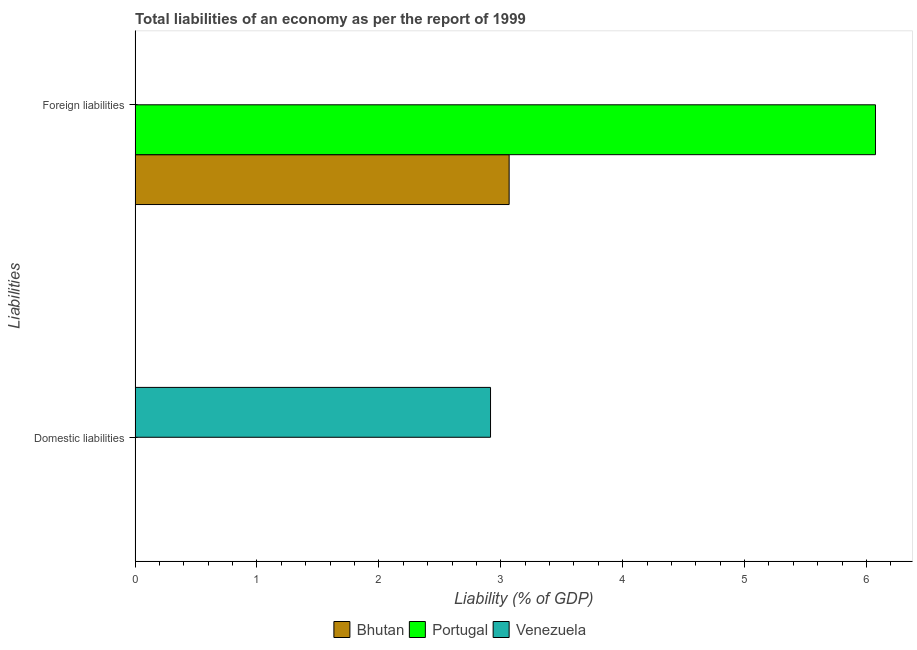How many different coloured bars are there?
Make the answer very short. 3. How many bars are there on the 2nd tick from the top?
Your answer should be very brief. 1. What is the label of the 2nd group of bars from the top?
Offer a very short reply. Domestic liabilities. What is the incurrence of foreign liabilities in Portugal?
Offer a very short reply. 6.07. Across all countries, what is the maximum incurrence of domestic liabilities?
Keep it short and to the point. 2.92. Across all countries, what is the minimum incurrence of domestic liabilities?
Provide a short and direct response. 0. What is the total incurrence of foreign liabilities in the graph?
Provide a short and direct response. 9.14. What is the difference between the incurrence of foreign liabilities in Portugal and that in Bhutan?
Give a very brief answer. 3.01. What is the difference between the incurrence of domestic liabilities in Venezuela and the incurrence of foreign liabilities in Portugal?
Ensure brevity in your answer.  -3.16. What is the average incurrence of domestic liabilities per country?
Keep it short and to the point. 0.97. In how many countries, is the incurrence of foreign liabilities greater than 4.4 %?
Give a very brief answer. 1. What is the ratio of the incurrence of foreign liabilities in Portugal to that in Bhutan?
Ensure brevity in your answer.  1.98. How many bars are there?
Offer a terse response. 3. Does the graph contain any zero values?
Offer a very short reply. Yes. Where does the legend appear in the graph?
Give a very brief answer. Bottom center. How many legend labels are there?
Make the answer very short. 3. How are the legend labels stacked?
Ensure brevity in your answer.  Horizontal. What is the title of the graph?
Provide a succinct answer. Total liabilities of an economy as per the report of 1999. Does "Sweden" appear as one of the legend labels in the graph?
Your answer should be very brief. No. What is the label or title of the X-axis?
Provide a short and direct response. Liability (% of GDP). What is the label or title of the Y-axis?
Offer a terse response. Liabilities. What is the Liability (% of GDP) of Venezuela in Domestic liabilities?
Make the answer very short. 2.92. What is the Liability (% of GDP) in Bhutan in Foreign liabilities?
Offer a very short reply. 3.07. What is the Liability (% of GDP) of Portugal in Foreign liabilities?
Ensure brevity in your answer.  6.07. What is the Liability (% of GDP) of Venezuela in Foreign liabilities?
Keep it short and to the point. 0. Across all Liabilities, what is the maximum Liability (% of GDP) of Bhutan?
Your answer should be compact. 3.07. Across all Liabilities, what is the maximum Liability (% of GDP) of Portugal?
Your answer should be compact. 6.07. Across all Liabilities, what is the maximum Liability (% of GDP) of Venezuela?
Give a very brief answer. 2.92. Across all Liabilities, what is the minimum Liability (% of GDP) in Portugal?
Provide a short and direct response. 0. Across all Liabilities, what is the minimum Liability (% of GDP) of Venezuela?
Your response must be concise. 0. What is the total Liability (% of GDP) in Bhutan in the graph?
Your response must be concise. 3.07. What is the total Liability (% of GDP) in Portugal in the graph?
Keep it short and to the point. 6.07. What is the total Liability (% of GDP) in Venezuela in the graph?
Give a very brief answer. 2.92. What is the average Liability (% of GDP) in Bhutan per Liabilities?
Your answer should be compact. 1.53. What is the average Liability (% of GDP) in Portugal per Liabilities?
Give a very brief answer. 3.04. What is the average Liability (% of GDP) of Venezuela per Liabilities?
Provide a short and direct response. 1.46. What is the difference between the Liability (% of GDP) of Bhutan and Liability (% of GDP) of Portugal in Foreign liabilities?
Make the answer very short. -3.01. What is the difference between the highest and the lowest Liability (% of GDP) of Bhutan?
Offer a terse response. 3.07. What is the difference between the highest and the lowest Liability (% of GDP) of Portugal?
Make the answer very short. 6.07. What is the difference between the highest and the lowest Liability (% of GDP) of Venezuela?
Offer a very short reply. 2.92. 